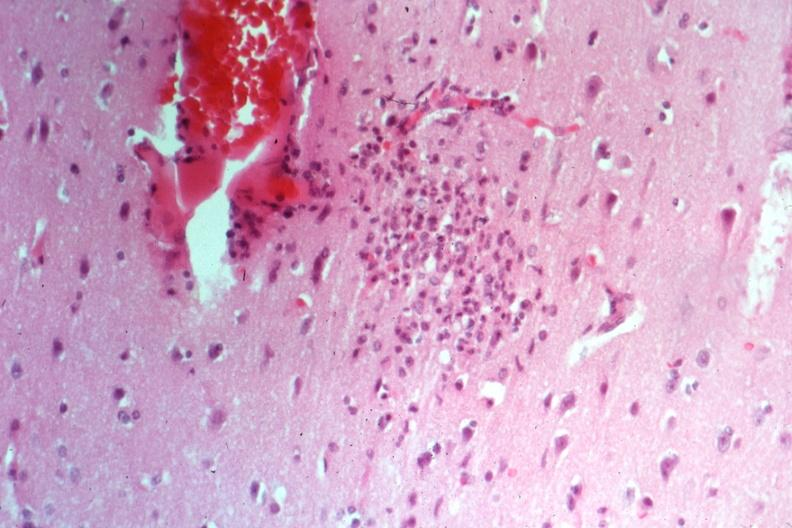does this image show typical nodule cause not known at this time?
Answer the question using a single word or phrase. Yes 